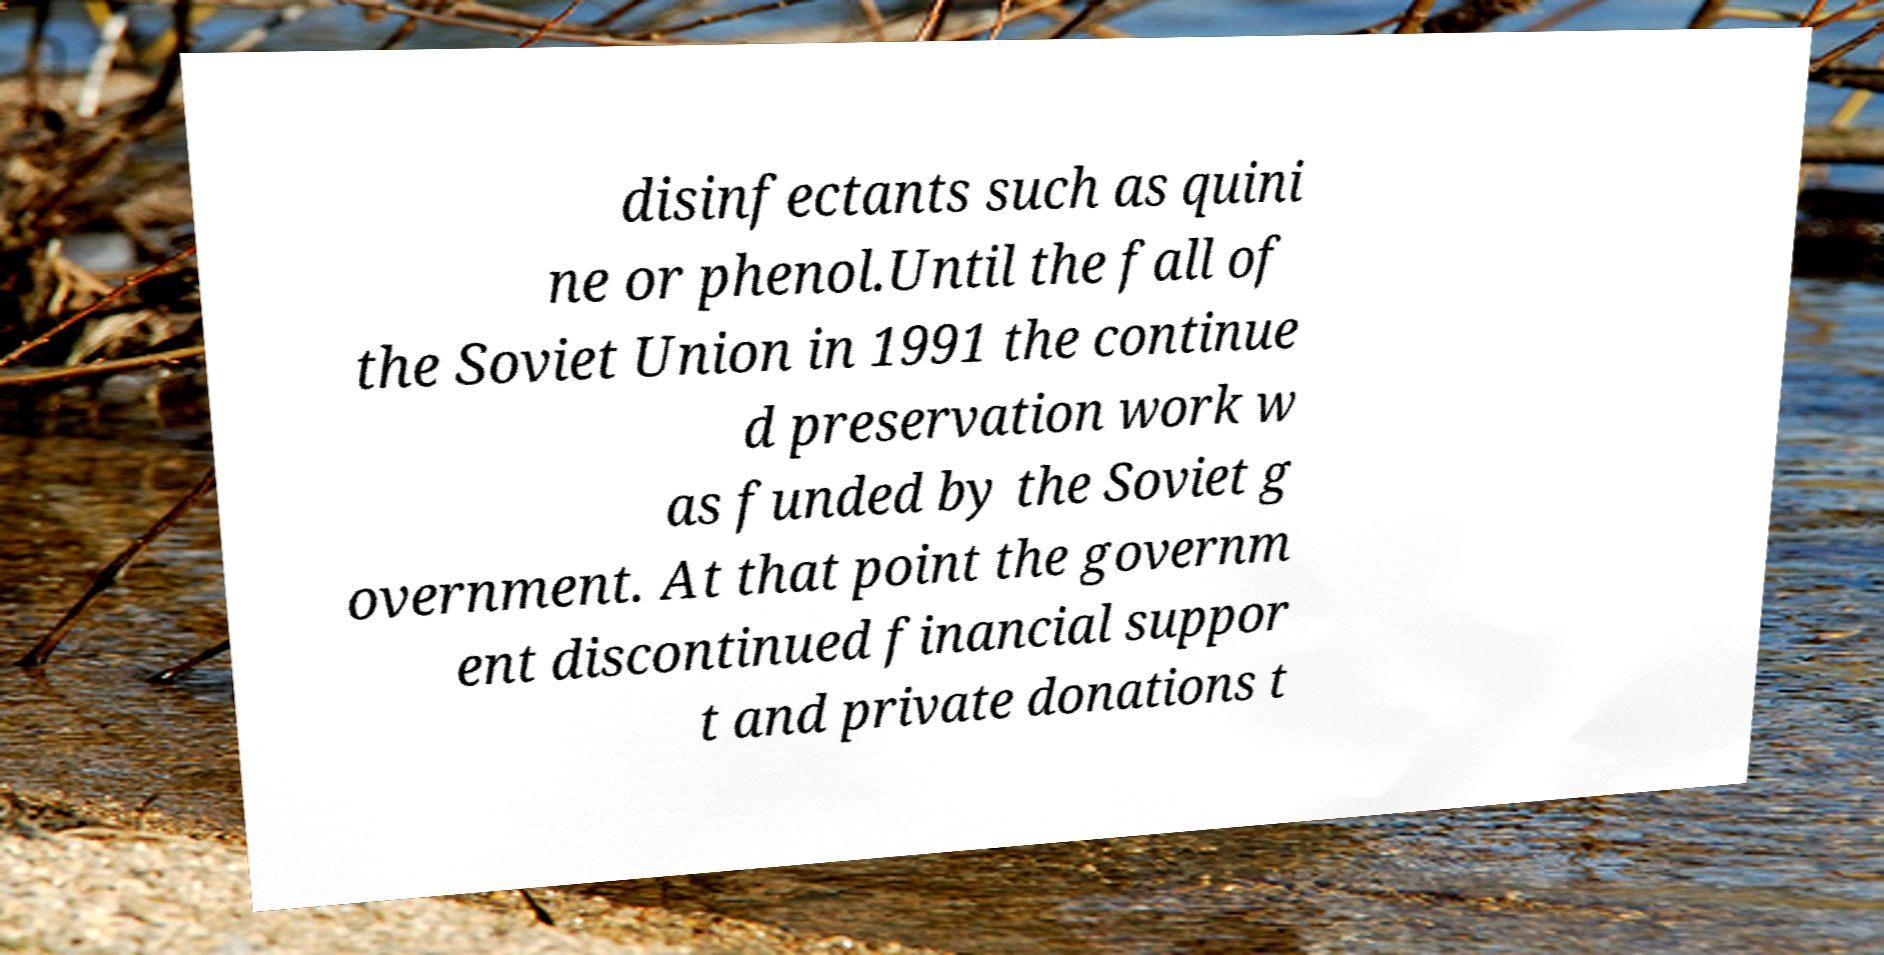I need the written content from this picture converted into text. Can you do that? disinfectants such as quini ne or phenol.Until the fall of the Soviet Union in 1991 the continue d preservation work w as funded by the Soviet g overnment. At that point the governm ent discontinued financial suppor t and private donations t 